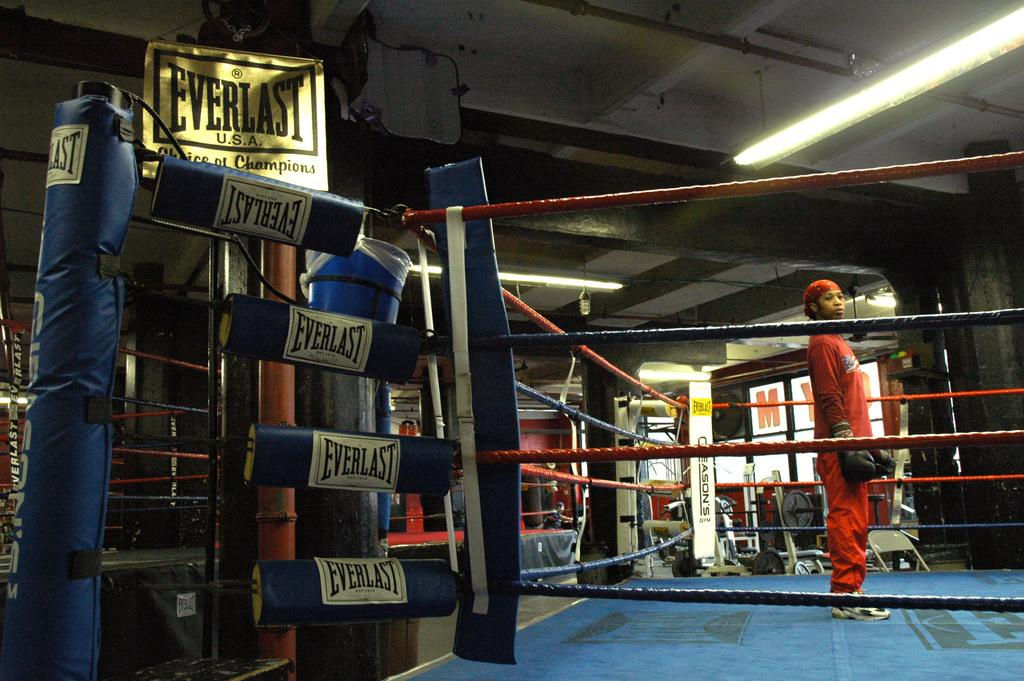<image>
Relay a brief, clear account of the picture shown. A boxing ring promoted by Everlast,  with a woman wearing an orange uniform 